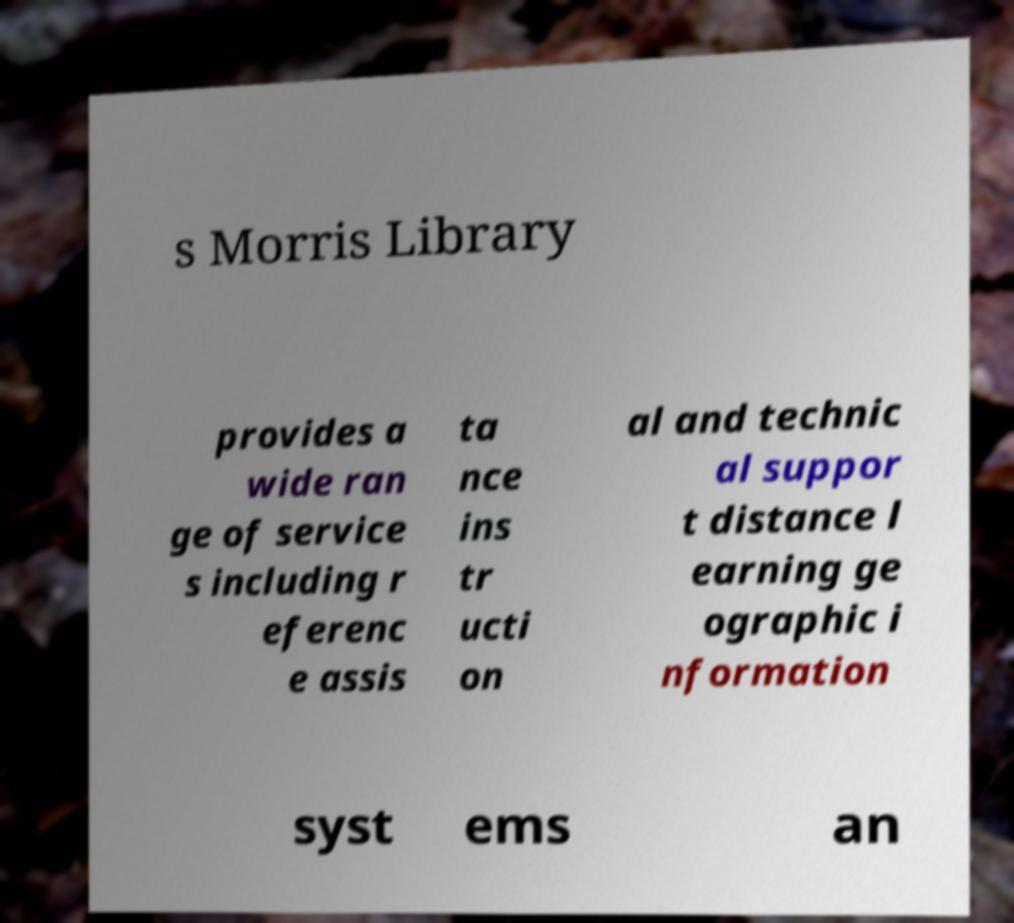Could you extract and type out the text from this image? s Morris Library provides a wide ran ge of service s including r eferenc e assis ta nce ins tr ucti on al and technic al suppor t distance l earning ge ographic i nformation syst ems an 